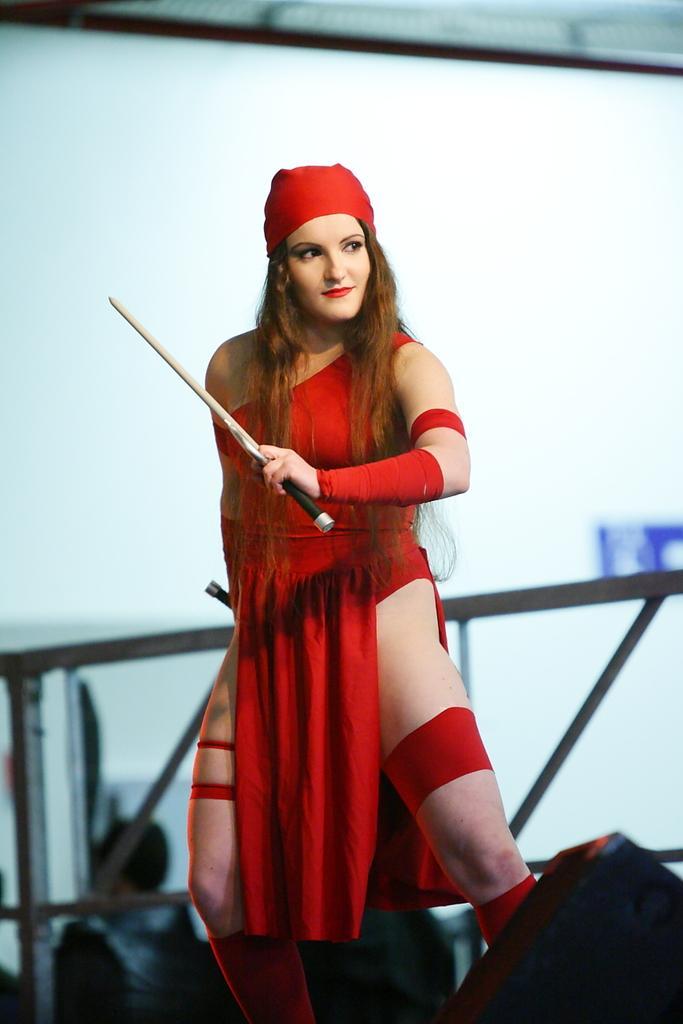Please provide a concise description of this image. In this image I can see a woman wearing red colored dress and holding a weapon in her hand. In the background I can see the metal railing, few persons and the white colored surface. 